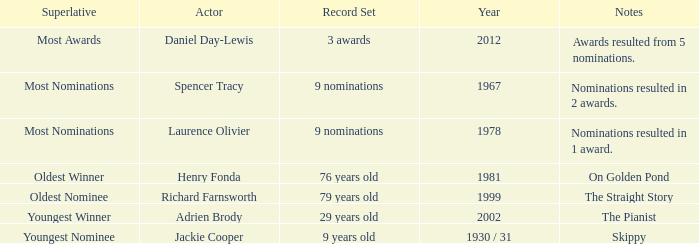What year did actor Richard Farnsworth get nominated for an award? 1999.0. 